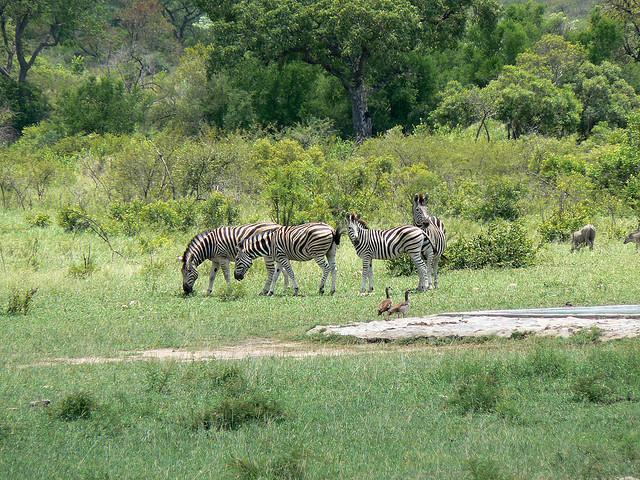How many zebras do you see?
Give a very brief answer. 4. How many zebras can you see?
Give a very brief answer. 3. 